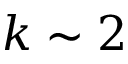Convert formula to latex. <formula><loc_0><loc_0><loc_500><loc_500>k \sim 2</formula> 